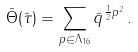<formula> <loc_0><loc_0><loc_500><loc_500>\bar { \Theta } ( \bar { \tau } ) = \sum _ { { p } \in \Lambda _ { 1 6 } } \bar { q } ^ { \frac { 1 } { 2 } { p } ^ { 2 } } \, .</formula> 